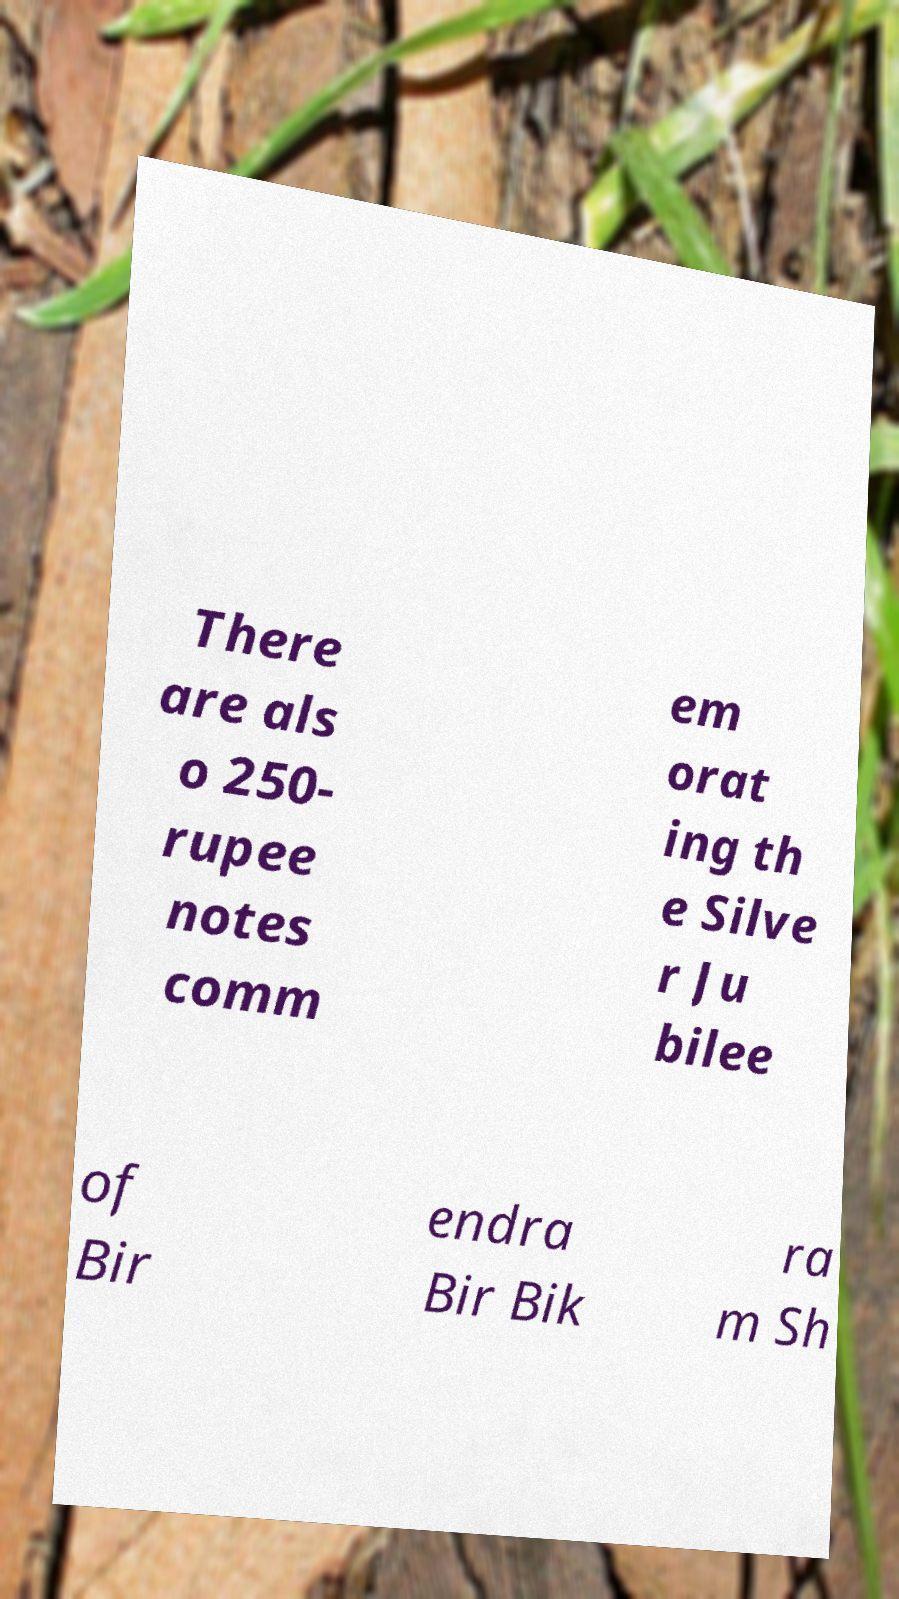Please read and relay the text visible in this image. What does it say? There are als o 250- rupee notes comm em orat ing th e Silve r Ju bilee of Bir endra Bir Bik ra m Sh 